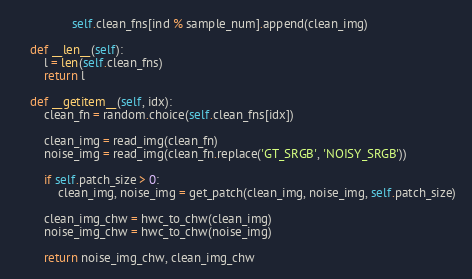Convert code to text. <code><loc_0><loc_0><loc_500><loc_500><_Python_>				self.clean_fns[ind % sample_num].append(clean_img)

	def __len__(self):
		l = len(self.clean_fns)
		return l

	def __getitem__(self, idx):
		clean_fn = random.choice(self.clean_fns[idx])

		clean_img = read_img(clean_fn)
		noise_img = read_img(clean_fn.replace('GT_SRGB', 'NOISY_SRGB'))

		if self.patch_size > 0:
			clean_img, noise_img = get_patch(clean_img, noise_img, self.patch_size)

		clean_img_chw = hwc_to_chw(clean_img)
		noise_img_chw = hwc_to_chw(noise_img)

		return noise_img_chw, clean_img_chw</code> 